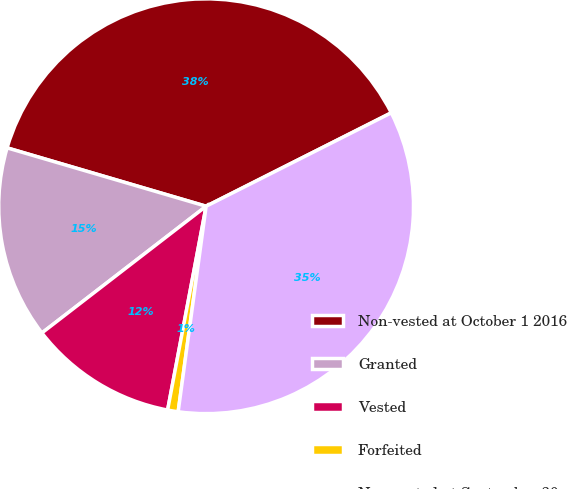Convert chart to OTSL. <chart><loc_0><loc_0><loc_500><loc_500><pie_chart><fcel>Non-vested at October 1 2016<fcel>Granted<fcel>Vested<fcel>Forfeited<fcel>Non-vested at September 30<nl><fcel>38.02%<fcel>15.0%<fcel>11.57%<fcel>0.82%<fcel>34.59%<nl></chart> 